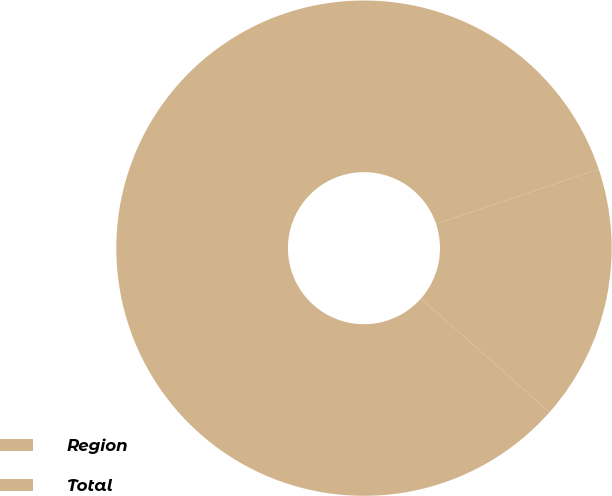Convert chart. <chart><loc_0><loc_0><loc_500><loc_500><pie_chart><fcel>Region<fcel>Total<nl><fcel>83.3%<fcel>16.7%<nl></chart> 